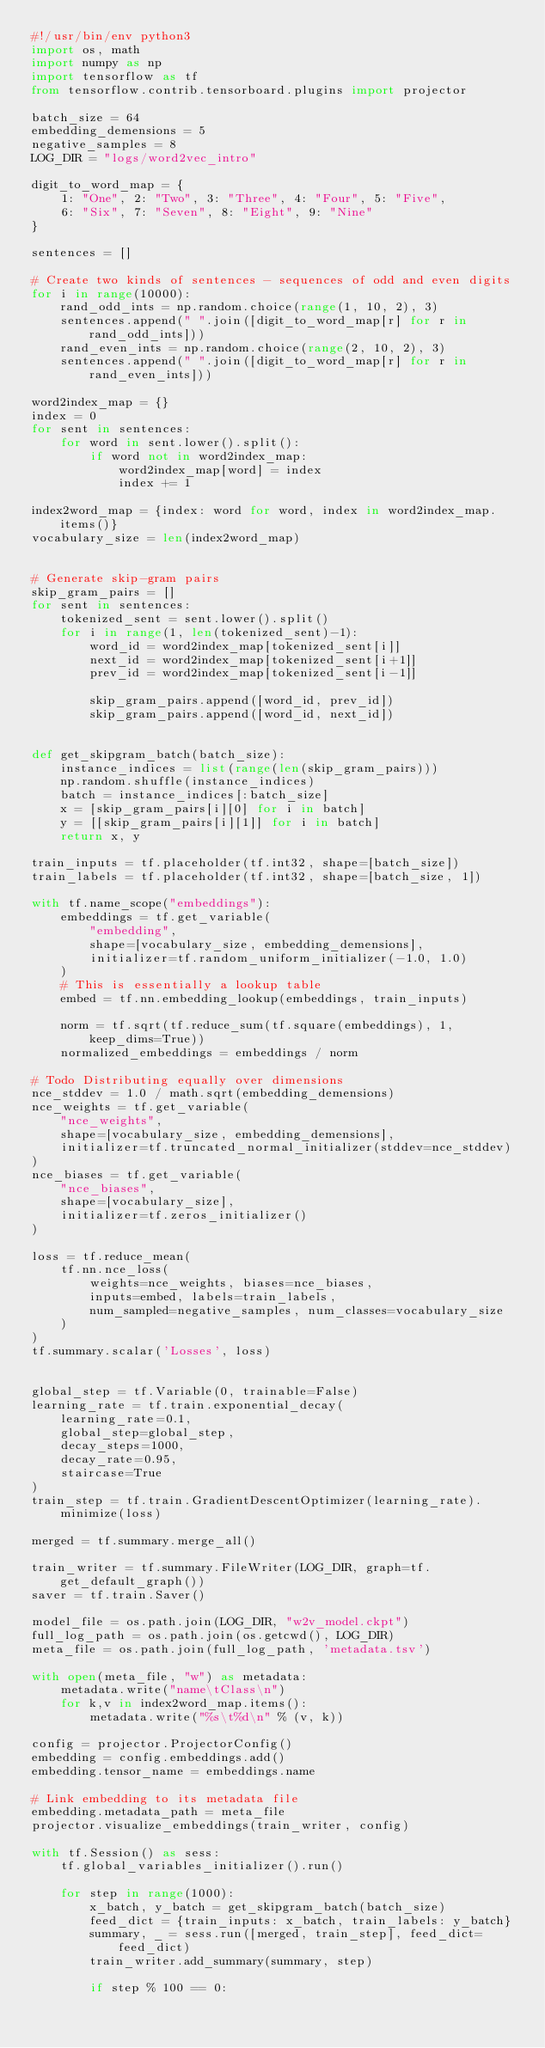<code> <loc_0><loc_0><loc_500><loc_500><_Python_>#!/usr/bin/env python3
import os, math
import numpy as np
import tensorflow as tf
from tensorflow.contrib.tensorboard.plugins import projector

batch_size = 64
embedding_demensions = 5
negative_samples = 8
LOG_DIR = "logs/word2vec_intro"

digit_to_word_map = {
    1: "One", 2: "Two", 3: "Three", 4: "Four", 5: "Five",
    6: "Six", 7: "Seven", 8: "Eight", 9: "Nine"
}

sentences = []

# Create two kinds of sentences - sequences of odd and even digits
for i in range(10000):
    rand_odd_ints = np.random.choice(range(1, 10, 2), 3)
    sentences.append(" ".join([digit_to_word_map[r] for r in rand_odd_ints]))
    rand_even_ints = np.random.choice(range(2, 10, 2), 3)
    sentences.append(" ".join([digit_to_word_map[r] for r in rand_even_ints]))

word2index_map = {}
index = 0
for sent in sentences:
    for word in sent.lower().split():
        if word not in word2index_map:
            word2index_map[word] = index
            index += 1

index2word_map = {index: word for word, index in word2index_map.items()}
vocabulary_size = len(index2word_map)


# Generate skip-gram pairs
skip_gram_pairs = []
for sent in sentences:
    tokenized_sent = sent.lower().split()
    for i in range(1, len(tokenized_sent)-1):
        word_id = word2index_map[tokenized_sent[i]]
        next_id = word2index_map[tokenized_sent[i+1]]
        prev_id = word2index_map[tokenized_sent[i-1]]

        skip_gram_pairs.append([word_id, prev_id])
        skip_gram_pairs.append([word_id, next_id])


def get_skipgram_batch(batch_size):
    instance_indices = list(range(len(skip_gram_pairs)))
    np.random.shuffle(instance_indices)
    batch = instance_indices[:batch_size]
    x = [skip_gram_pairs[i][0] for i in batch]
    y = [[skip_gram_pairs[i][1]] for i in batch]
    return x, y

train_inputs = tf.placeholder(tf.int32, shape=[batch_size])
train_labels = tf.placeholder(tf.int32, shape=[batch_size, 1])

with tf.name_scope("embeddings"):
    embeddings = tf.get_variable(
        "embedding",
        shape=[vocabulary_size, embedding_demensions],
        initializer=tf.random_uniform_initializer(-1.0, 1.0)
    )
    # This is essentially a lookup table
    embed = tf.nn.embedding_lookup(embeddings, train_inputs)

    norm = tf.sqrt(tf.reduce_sum(tf.square(embeddings), 1, keep_dims=True))
    normalized_embeddings = embeddings / norm

# Todo Distributing equally over dimensions
nce_stddev = 1.0 / math.sqrt(embedding_demensions)
nce_weights = tf.get_variable(
    "nce_weights",
    shape=[vocabulary_size, embedding_demensions],
    initializer=tf.truncated_normal_initializer(stddev=nce_stddev)
)
nce_biases = tf.get_variable(
    "nce_biases",
    shape=[vocabulary_size],
    initializer=tf.zeros_initializer()
)

loss = tf.reduce_mean(
    tf.nn.nce_loss(
        weights=nce_weights, biases=nce_biases,
        inputs=embed, labels=train_labels,
        num_sampled=negative_samples, num_classes=vocabulary_size
    )
)
tf.summary.scalar('Losses', loss)


global_step = tf.Variable(0, trainable=False)
learning_rate = tf.train.exponential_decay(
    learning_rate=0.1,
    global_step=global_step,
    decay_steps=1000,
    decay_rate=0.95,
    staircase=True
)
train_step = tf.train.GradientDescentOptimizer(learning_rate).minimize(loss)

merged = tf.summary.merge_all()

train_writer = tf.summary.FileWriter(LOG_DIR, graph=tf.get_default_graph())
saver = tf.train.Saver()

model_file = os.path.join(LOG_DIR, "w2v_model.ckpt")
full_log_path = os.path.join(os.getcwd(), LOG_DIR)
meta_file = os.path.join(full_log_path, 'metadata.tsv')

with open(meta_file, "w") as metadata:
    metadata.write("name\tClass\n")
    for k,v in index2word_map.items():
        metadata.write("%s\t%d\n" % (v, k))

config = projector.ProjectorConfig()
embedding = config.embeddings.add()
embedding.tensor_name = embeddings.name

# Link embedding to its metadata file
embedding.metadata_path = meta_file
projector.visualize_embeddings(train_writer, config)

with tf.Session() as sess:
    tf.global_variables_initializer().run()

    for step in range(1000):
        x_batch, y_batch = get_skipgram_batch(batch_size)
        feed_dict = {train_inputs: x_batch, train_labels: y_batch}
        summary, _ = sess.run([merged, train_step], feed_dict=feed_dict)
        train_writer.add_summary(summary, step)

        if step % 100 == 0:</code> 